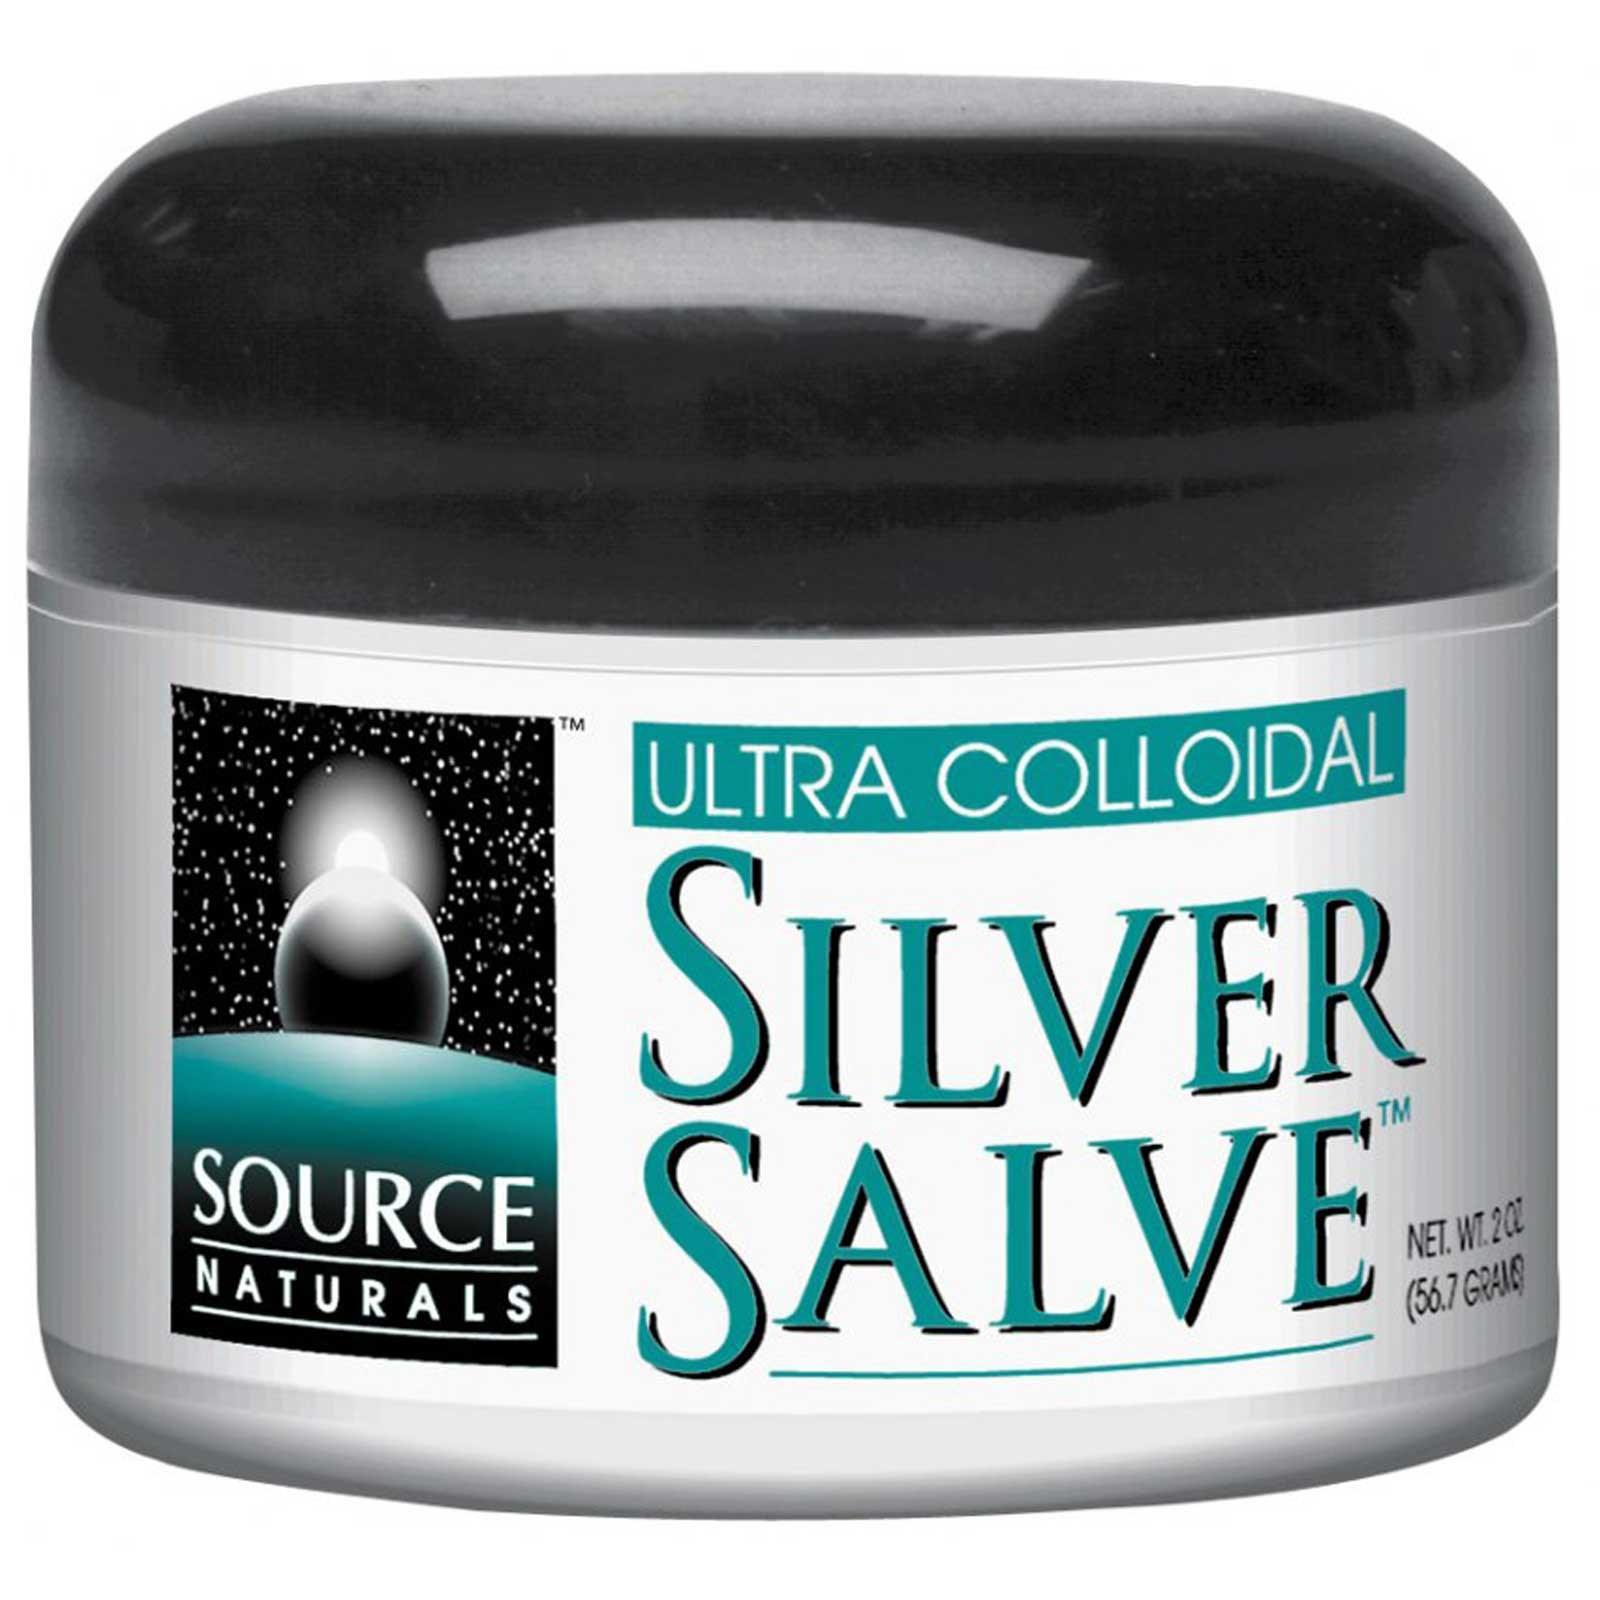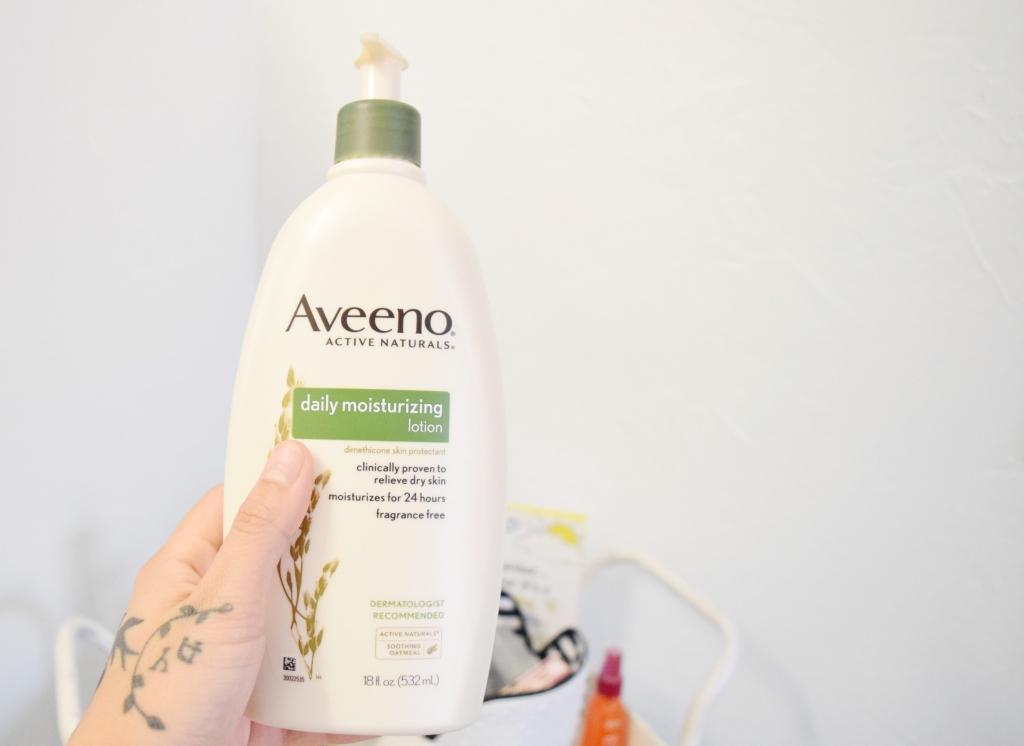The first image is the image on the left, the second image is the image on the right. Evaluate the accuracy of this statement regarding the images: "At least one image contains red markings on the package.". Is it true? Answer yes or no. No. 